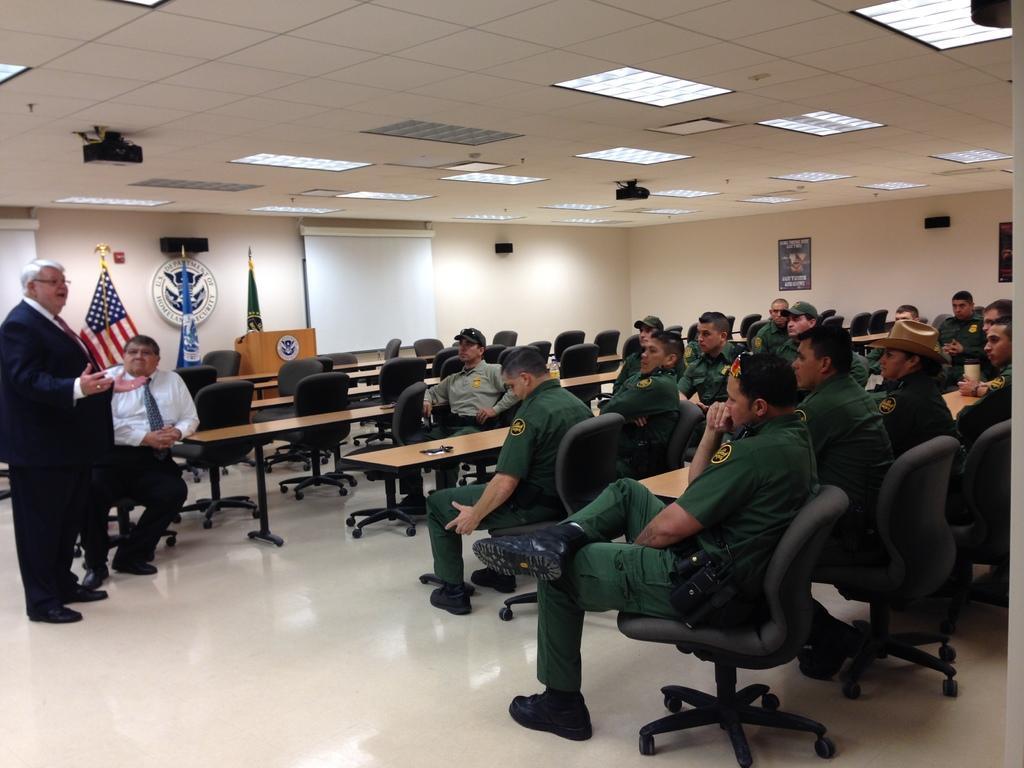Please provide a concise description of this image. In this image I see people and most of them are sitting on chairs and this man wearing a suit is standing over here and I see that these men are wearing uniforms and there are tables in front of them. In the background I see 3 flags, a logo, podium, white screen and lights on the ceiling. 